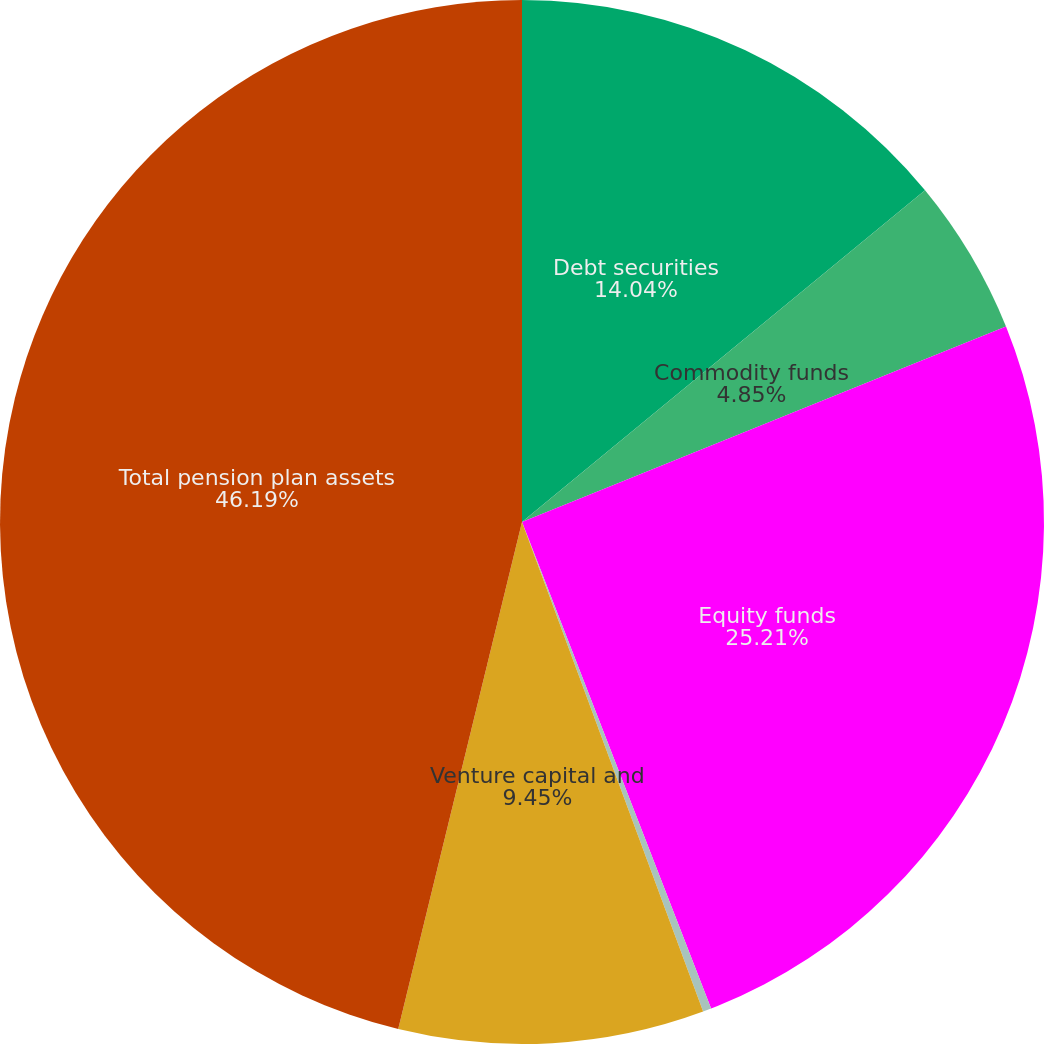<chart> <loc_0><loc_0><loc_500><loc_500><pie_chart><fcel>Debt securities<fcel>Commodity funds<fcel>Equity funds<fcel>Short-term funds<fcel>Venture capital and<fcel>Total pension plan assets<nl><fcel>14.04%<fcel>4.85%<fcel>25.21%<fcel>0.26%<fcel>9.45%<fcel>46.19%<nl></chart> 